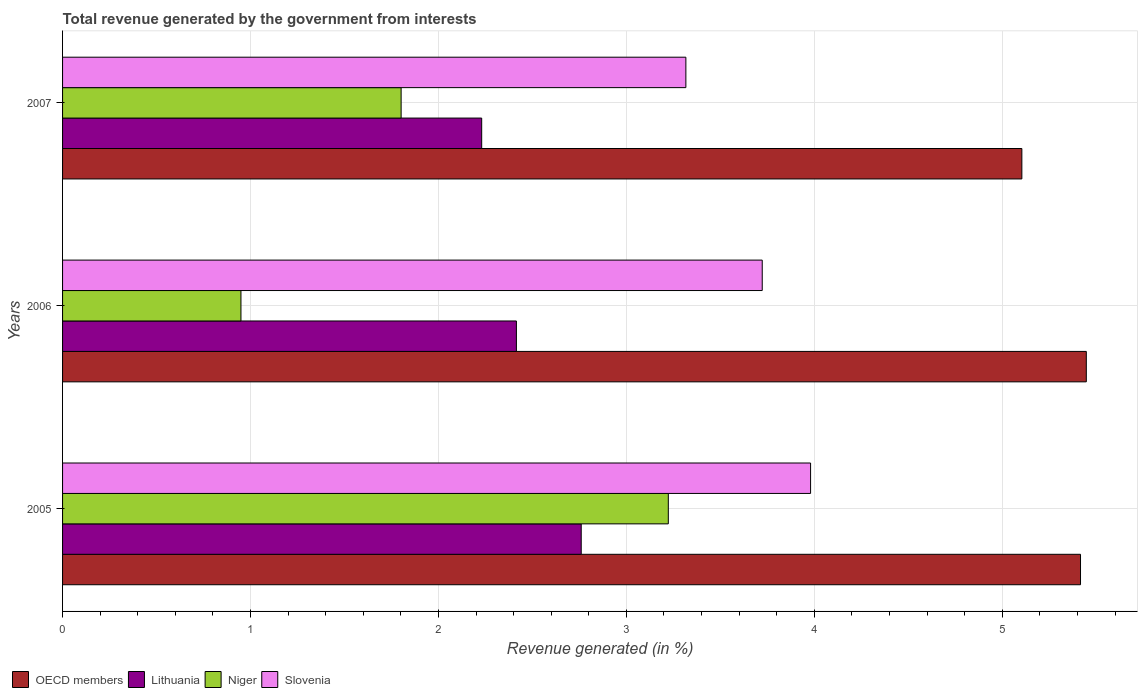How many groups of bars are there?
Ensure brevity in your answer.  3. Are the number of bars per tick equal to the number of legend labels?
Your answer should be very brief. Yes. Are the number of bars on each tick of the Y-axis equal?
Ensure brevity in your answer.  Yes. How many bars are there on the 2nd tick from the top?
Provide a succinct answer. 4. How many bars are there on the 1st tick from the bottom?
Give a very brief answer. 4. What is the label of the 1st group of bars from the top?
Your answer should be very brief. 2007. What is the total revenue generated in Niger in 2006?
Your answer should be compact. 0.95. Across all years, what is the maximum total revenue generated in OECD members?
Offer a terse response. 5.45. Across all years, what is the minimum total revenue generated in Lithuania?
Your answer should be compact. 2.23. In which year was the total revenue generated in Lithuania minimum?
Ensure brevity in your answer.  2007. What is the total total revenue generated in Niger in the graph?
Your response must be concise. 5.97. What is the difference between the total revenue generated in Lithuania in 2005 and that in 2006?
Your answer should be compact. 0.34. What is the difference between the total revenue generated in Lithuania in 2005 and the total revenue generated in OECD members in 2007?
Your response must be concise. -2.34. What is the average total revenue generated in Slovenia per year?
Provide a succinct answer. 3.67. In the year 2007, what is the difference between the total revenue generated in Slovenia and total revenue generated in Niger?
Offer a very short reply. 1.52. In how many years, is the total revenue generated in Niger greater than 3.8 %?
Give a very brief answer. 0. What is the ratio of the total revenue generated in Lithuania in 2006 to that in 2007?
Make the answer very short. 1.08. What is the difference between the highest and the second highest total revenue generated in Lithuania?
Provide a short and direct response. 0.34. What is the difference between the highest and the lowest total revenue generated in Slovenia?
Make the answer very short. 0.66. What does the 1st bar from the top in 2006 represents?
Provide a succinct answer. Slovenia. What does the 3rd bar from the bottom in 2006 represents?
Provide a short and direct response. Niger. Is it the case that in every year, the sum of the total revenue generated in OECD members and total revenue generated in Lithuania is greater than the total revenue generated in Slovenia?
Make the answer very short. Yes. Are all the bars in the graph horizontal?
Your answer should be compact. Yes. How many years are there in the graph?
Keep it short and to the point. 3. Does the graph contain grids?
Provide a succinct answer. Yes. What is the title of the graph?
Provide a short and direct response. Total revenue generated by the government from interests. What is the label or title of the X-axis?
Ensure brevity in your answer.  Revenue generated (in %). What is the Revenue generated (in %) in OECD members in 2005?
Give a very brief answer. 5.42. What is the Revenue generated (in %) of Lithuania in 2005?
Provide a short and direct response. 2.76. What is the Revenue generated (in %) of Niger in 2005?
Provide a succinct answer. 3.22. What is the Revenue generated (in %) in Slovenia in 2005?
Offer a very short reply. 3.98. What is the Revenue generated (in %) of OECD members in 2006?
Provide a succinct answer. 5.45. What is the Revenue generated (in %) in Lithuania in 2006?
Provide a succinct answer. 2.41. What is the Revenue generated (in %) in Niger in 2006?
Your answer should be compact. 0.95. What is the Revenue generated (in %) in Slovenia in 2006?
Your response must be concise. 3.72. What is the Revenue generated (in %) of OECD members in 2007?
Make the answer very short. 5.1. What is the Revenue generated (in %) in Lithuania in 2007?
Offer a terse response. 2.23. What is the Revenue generated (in %) in Niger in 2007?
Make the answer very short. 1.8. What is the Revenue generated (in %) in Slovenia in 2007?
Keep it short and to the point. 3.32. Across all years, what is the maximum Revenue generated (in %) in OECD members?
Offer a terse response. 5.45. Across all years, what is the maximum Revenue generated (in %) of Lithuania?
Provide a short and direct response. 2.76. Across all years, what is the maximum Revenue generated (in %) of Niger?
Your response must be concise. 3.22. Across all years, what is the maximum Revenue generated (in %) of Slovenia?
Ensure brevity in your answer.  3.98. Across all years, what is the minimum Revenue generated (in %) of OECD members?
Your response must be concise. 5.1. Across all years, what is the minimum Revenue generated (in %) of Lithuania?
Offer a very short reply. 2.23. Across all years, what is the minimum Revenue generated (in %) of Niger?
Offer a terse response. 0.95. Across all years, what is the minimum Revenue generated (in %) in Slovenia?
Ensure brevity in your answer.  3.32. What is the total Revenue generated (in %) of OECD members in the graph?
Offer a very short reply. 15.97. What is the total Revenue generated (in %) of Lithuania in the graph?
Give a very brief answer. 7.4. What is the total Revenue generated (in %) in Niger in the graph?
Provide a succinct answer. 5.97. What is the total Revenue generated (in %) of Slovenia in the graph?
Your answer should be very brief. 11.02. What is the difference between the Revenue generated (in %) of OECD members in 2005 and that in 2006?
Provide a short and direct response. -0.03. What is the difference between the Revenue generated (in %) in Lithuania in 2005 and that in 2006?
Provide a short and direct response. 0.34. What is the difference between the Revenue generated (in %) of Niger in 2005 and that in 2006?
Offer a very short reply. 2.27. What is the difference between the Revenue generated (in %) of Slovenia in 2005 and that in 2006?
Your answer should be very brief. 0.26. What is the difference between the Revenue generated (in %) in OECD members in 2005 and that in 2007?
Keep it short and to the point. 0.31. What is the difference between the Revenue generated (in %) in Lithuania in 2005 and that in 2007?
Offer a terse response. 0.53. What is the difference between the Revenue generated (in %) of Niger in 2005 and that in 2007?
Keep it short and to the point. 1.42. What is the difference between the Revenue generated (in %) of Slovenia in 2005 and that in 2007?
Give a very brief answer. 0.66. What is the difference between the Revenue generated (in %) of OECD members in 2006 and that in 2007?
Make the answer very short. 0.34. What is the difference between the Revenue generated (in %) of Lithuania in 2006 and that in 2007?
Your response must be concise. 0.18. What is the difference between the Revenue generated (in %) of Niger in 2006 and that in 2007?
Give a very brief answer. -0.85. What is the difference between the Revenue generated (in %) in Slovenia in 2006 and that in 2007?
Keep it short and to the point. 0.41. What is the difference between the Revenue generated (in %) of OECD members in 2005 and the Revenue generated (in %) of Lithuania in 2006?
Keep it short and to the point. 3. What is the difference between the Revenue generated (in %) of OECD members in 2005 and the Revenue generated (in %) of Niger in 2006?
Ensure brevity in your answer.  4.47. What is the difference between the Revenue generated (in %) in OECD members in 2005 and the Revenue generated (in %) in Slovenia in 2006?
Make the answer very short. 1.69. What is the difference between the Revenue generated (in %) of Lithuania in 2005 and the Revenue generated (in %) of Niger in 2006?
Make the answer very short. 1.81. What is the difference between the Revenue generated (in %) in Lithuania in 2005 and the Revenue generated (in %) in Slovenia in 2006?
Make the answer very short. -0.96. What is the difference between the Revenue generated (in %) in Niger in 2005 and the Revenue generated (in %) in Slovenia in 2006?
Make the answer very short. -0.5. What is the difference between the Revenue generated (in %) in OECD members in 2005 and the Revenue generated (in %) in Lithuania in 2007?
Provide a short and direct response. 3.19. What is the difference between the Revenue generated (in %) in OECD members in 2005 and the Revenue generated (in %) in Niger in 2007?
Make the answer very short. 3.61. What is the difference between the Revenue generated (in %) of OECD members in 2005 and the Revenue generated (in %) of Slovenia in 2007?
Give a very brief answer. 2.1. What is the difference between the Revenue generated (in %) in Lithuania in 2005 and the Revenue generated (in %) in Niger in 2007?
Offer a very short reply. 0.96. What is the difference between the Revenue generated (in %) of Lithuania in 2005 and the Revenue generated (in %) of Slovenia in 2007?
Offer a terse response. -0.56. What is the difference between the Revenue generated (in %) in Niger in 2005 and the Revenue generated (in %) in Slovenia in 2007?
Your answer should be compact. -0.09. What is the difference between the Revenue generated (in %) of OECD members in 2006 and the Revenue generated (in %) of Lithuania in 2007?
Your response must be concise. 3.22. What is the difference between the Revenue generated (in %) of OECD members in 2006 and the Revenue generated (in %) of Niger in 2007?
Make the answer very short. 3.65. What is the difference between the Revenue generated (in %) in OECD members in 2006 and the Revenue generated (in %) in Slovenia in 2007?
Give a very brief answer. 2.13. What is the difference between the Revenue generated (in %) of Lithuania in 2006 and the Revenue generated (in %) of Niger in 2007?
Ensure brevity in your answer.  0.61. What is the difference between the Revenue generated (in %) in Lithuania in 2006 and the Revenue generated (in %) in Slovenia in 2007?
Offer a very short reply. -0.9. What is the difference between the Revenue generated (in %) in Niger in 2006 and the Revenue generated (in %) in Slovenia in 2007?
Make the answer very short. -2.37. What is the average Revenue generated (in %) in OECD members per year?
Your response must be concise. 5.32. What is the average Revenue generated (in %) of Lithuania per year?
Ensure brevity in your answer.  2.47. What is the average Revenue generated (in %) of Niger per year?
Your response must be concise. 1.99. What is the average Revenue generated (in %) in Slovenia per year?
Your response must be concise. 3.67. In the year 2005, what is the difference between the Revenue generated (in %) of OECD members and Revenue generated (in %) of Lithuania?
Provide a succinct answer. 2.66. In the year 2005, what is the difference between the Revenue generated (in %) in OECD members and Revenue generated (in %) in Niger?
Offer a terse response. 2.19. In the year 2005, what is the difference between the Revenue generated (in %) in OECD members and Revenue generated (in %) in Slovenia?
Give a very brief answer. 1.44. In the year 2005, what is the difference between the Revenue generated (in %) of Lithuania and Revenue generated (in %) of Niger?
Your answer should be compact. -0.46. In the year 2005, what is the difference between the Revenue generated (in %) of Lithuania and Revenue generated (in %) of Slovenia?
Your response must be concise. -1.22. In the year 2005, what is the difference between the Revenue generated (in %) of Niger and Revenue generated (in %) of Slovenia?
Offer a very short reply. -0.76. In the year 2006, what is the difference between the Revenue generated (in %) of OECD members and Revenue generated (in %) of Lithuania?
Offer a very short reply. 3.03. In the year 2006, what is the difference between the Revenue generated (in %) in OECD members and Revenue generated (in %) in Niger?
Your response must be concise. 4.5. In the year 2006, what is the difference between the Revenue generated (in %) of OECD members and Revenue generated (in %) of Slovenia?
Your answer should be very brief. 1.72. In the year 2006, what is the difference between the Revenue generated (in %) of Lithuania and Revenue generated (in %) of Niger?
Provide a short and direct response. 1.47. In the year 2006, what is the difference between the Revenue generated (in %) of Lithuania and Revenue generated (in %) of Slovenia?
Provide a short and direct response. -1.31. In the year 2006, what is the difference between the Revenue generated (in %) in Niger and Revenue generated (in %) in Slovenia?
Give a very brief answer. -2.77. In the year 2007, what is the difference between the Revenue generated (in %) in OECD members and Revenue generated (in %) in Lithuania?
Provide a succinct answer. 2.87. In the year 2007, what is the difference between the Revenue generated (in %) in OECD members and Revenue generated (in %) in Niger?
Provide a succinct answer. 3.3. In the year 2007, what is the difference between the Revenue generated (in %) in OECD members and Revenue generated (in %) in Slovenia?
Provide a succinct answer. 1.79. In the year 2007, what is the difference between the Revenue generated (in %) in Lithuania and Revenue generated (in %) in Niger?
Offer a very short reply. 0.43. In the year 2007, what is the difference between the Revenue generated (in %) of Lithuania and Revenue generated (in %) of Slovenia?
Give a very brief answer. -1.09. In the year 2007, what is the difference between the Revenue generated (in %) in Niger and Revenue generated (in %) in Slovenia?
Offer a very short reply. -1.52. What is the ratio of the Revenue generated (in %) in OECD members in 2005 to that in 2006?
Offer a very short reply. 0.99. What is the ratio of the Revenue generated (in %) of Lithuania in 2005 to that in 2006?
Ensure brevity in your answer.  1.14. What is the ratio of the Revenue generated (in %) of Niger in 2005 to that in 2006?
Provide a short and direct response. 3.4. What is the ratio of the Revenue generated (in %) in Slovenia in 2005 to that in 2006?
Offer a very short reply. 1.07. What is the ratio of the Revenue generated (in %) in OECD members in 2005 to that in 2007?
Your answer should be very brief. 1.06. What is the ratio of the Revenue generated (in %) of Lithuania in 2005 to that in 2007?
Ensure brevity in your answer.  1.24. What is the ratio of the Revenue generated (in %) in Niger in 2005 to that in 2007?
Provide a short and direct response. 1.79. What is the ratio of the Revenue generated (in %) of OECD members in 2006 to that in 2007?
Your answer should be compact. 1.07. What is the ratio of the Revenue generated (in %) of Lithuania in 2006 to that in 2007?
Offer a terse response. 1.08. What is the ratio of the Revenue generated (in %) in Niger in 2006 to that in 2007?
Give a very brief answer. 0.53. What is the ratio of the Revenue generated (in %) of Slovenia in 2006 to that in 2007?
Give a very brief answer. 1.12. What is the difference between the highest and the second highest Revenue generated (in %) in OECD members?
Your answer should be very brief. 0.03. What is the difference between the highest and the second highest Revenue generated (in %) of Lithuania?
Your answer should be compact. 0.34. What is the difference between the highest and the second highest Revenue generated (in %) in Niger?
Ensure brevity in your answer.  1.42. What is the difference between the highest and the second highest Revenue generated (in %) in Slovenia?
Your response must be concise. 0.26. What is the difference between the highest and the lowest Revenue generated (in %) in OECD members?
Make the answer very short. 0.34. What is the difference between the highest and the lowest Revenue generated (in %) in Lithuania?
Keep it short and to the point. 0.53. What is the difference between the highest and the lowest Revenue generated (in %) of Niger?
Provide a succinct answer. 2.27. What is the difference between the highest and the lowest Revenue generated (in %) of Slovenia?
Offer a very short reply. 0.66. 